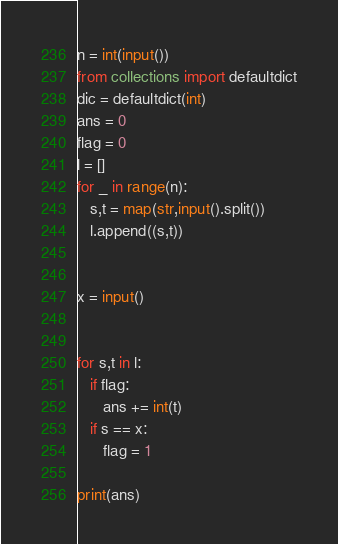Convert code to text. <code><loc_0><loc_0><loc_500><loc_500><_Python_>n = int(input())
from collections import defaultdict
dic = defaultdict(int)
ans = 0
flag = 0
l = []
for _ in range(n):
   s,t = map(str,input().split())
   l.append((s,t))


x = input()


for s,t in l:
   if flag:
      ans += int(t)
   if s == x:
      flag = 1
   
print(ans)</code> 